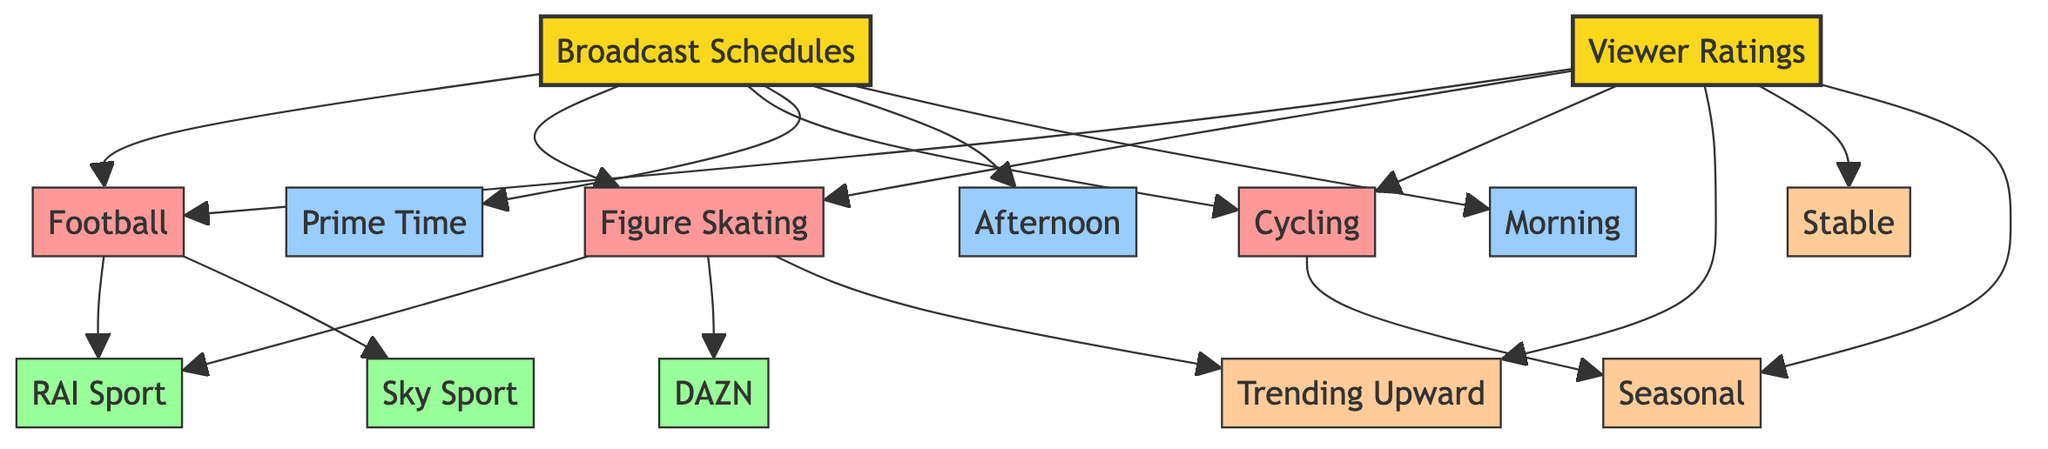What are the main categories of broadcast schedules? The diagram lists three main categories under broadcast schedules: Football, Figure Skating, and Cycling. By looking at the nodes connected directly to the Broadcast Schedules node, we can identify these categories.
Answer: Football, Figure Skating, Cycling Which channels broadcast Figure Skating? The channels associated with Figure Skating in the diagram are RAI Sport and DAZN. By examining the connections from the Figure Skating node, we can pinpoint these channels.
Answer: RAI Sport, DAZN What viewer rating trend is associated with Football? According to the diagram, the viewer rating trend associated with Football is Stable. The viewer rating node shows trends leading from multiple sports categories, and Football points to the Stable trend.
Answer: Stable How many subcategories are listed under Broadcast Schedules? The diagram shows three subcategories under Broadcast Schedules: Prime Time, Afternoon, and Morning. By counting the nodes connected to the Broadcast Schedules node, we find this total.
Answer: 3 Which trend is Figure Skating associated with? The Figure Skating category is linked to the Trending Upward node in the viewer ratings section. By checking the connections from the Figure Skating node, the associated trend can be determined.
Answer: Trending Upward Which channel broadcasts both Football and Figure Skating? The channel that broadcasts both Football and Figure Skating is RAI Sport. By following the links from both sports categories to their respective channels, RAI Sport appears in both cases.
Answer: RAI Sport What is the relationship between Cycling and viewer ratings? The relationship is that Cycling is associated with a Seasonal trend in viewer ratings. Looking at the connections under the viewer ratings node, we see Cycling links to the Seasonal trend node.
Answer: Seasonal How many viewer rating trends are represented in the diagram? The diagram represents three viewer rating trends: Trending Upward, Stable, and Seasonal. By counting the separate trend nodes connected to the Viewer Ratings category, we reach this total.
Answer: 3 